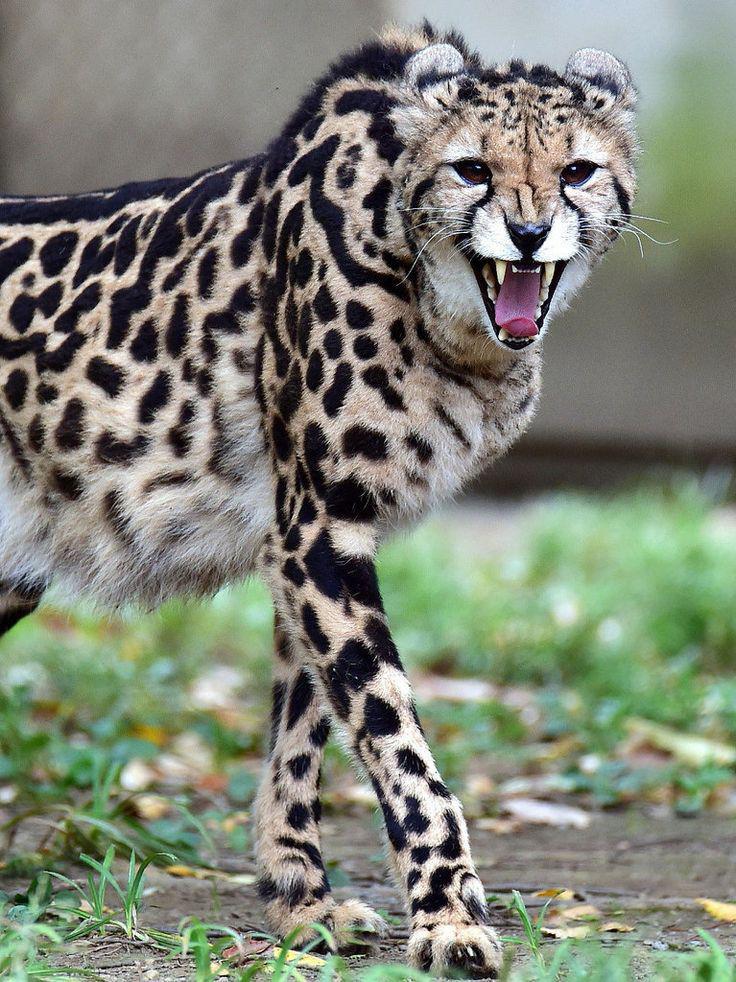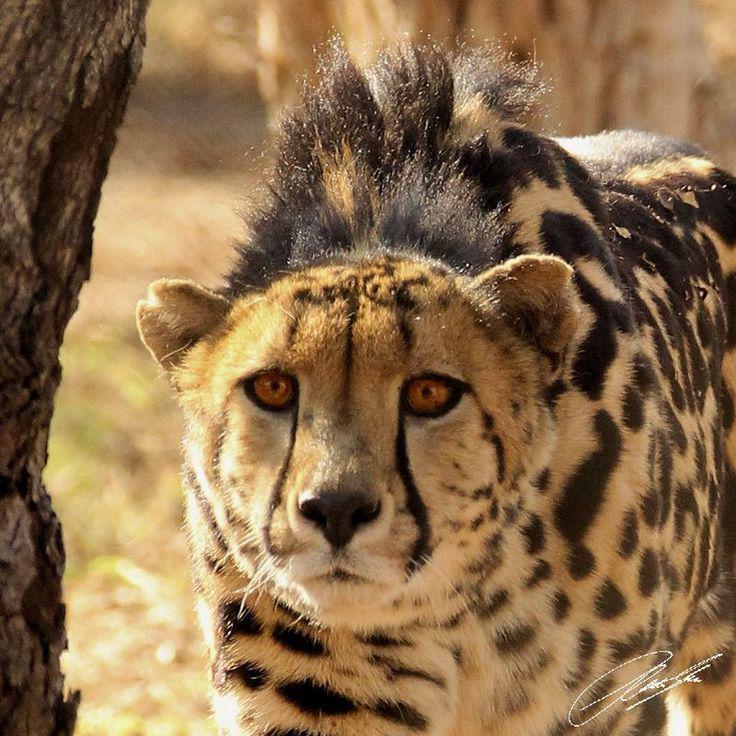The first image is the image on the left, the second image is the image on the right. For the images shown, is this caption "The left image shows a close-mouthed cheetah with a ridge of dark hair running from its head like a mane and its body in profile." true? Answer yes or no. No. The first image is the image on the left, the second image is the image on the right. Examine the images to the left and right. Is the description "There are two animals in total." accurate? Answer yes or no. Yes. 